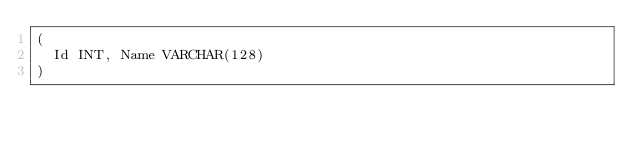Convert code to text. <code><loc_0><loc_0><loc_500><loc_500><_SQL_>(
	Id INT, Name VARCHAR(128)
)
</code> 